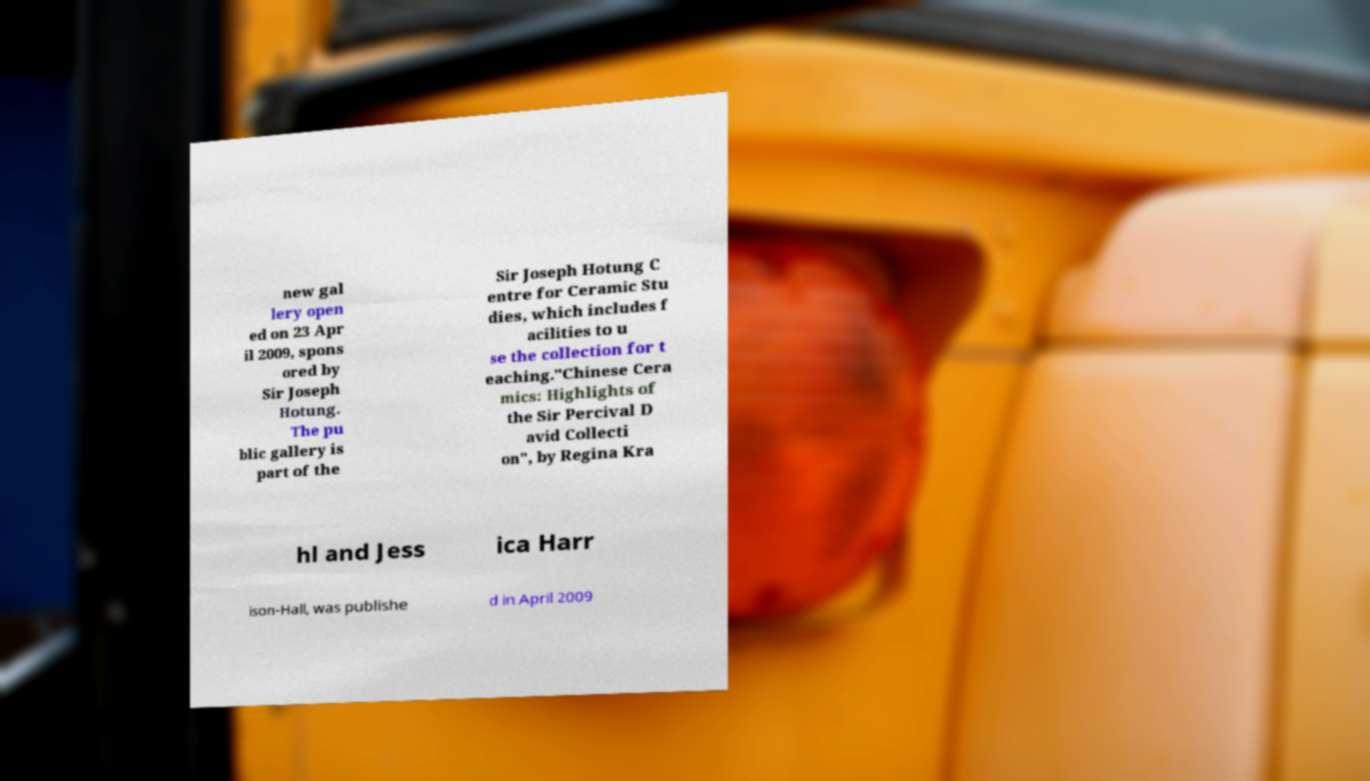What messages or text are displayed in this image? I need them in a readable, typed format. new gal lery open ed on 23 Apr il 2009, spons ored by Sir Joseph Hotung. The pu blic gallery is part of the Sir Joseph Hotung C entre for Ceramic Stu dies, which includes f acilities to u se the collection for t eaching."Chinese Cera mics: Highlights of the Sir Percival D avid Collecti on", by Regina Kra hl and Jess ica Harr ison-Hall, was publishe d in April 2009 